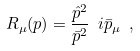<formula> <loc_0><loc_0><loc_500><loc_500>R _ { \mu } ( p ) = \frac { \hat { p } ^ { 2 } } { \bar { p } ^ { 2 } } \ i \bar { p } _ { \mu } \ ,</formula> 